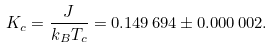Convert formula to latex. <formula><loc_0><loc_0><loc_500><loc_500>K _ { c } = \frac { J } { k _ { B } T _ { c } } = 0 . 1 4 9 \, 6 9 4 \pm 0 . 0 0 0 \, 0 0 2 .</formula> 